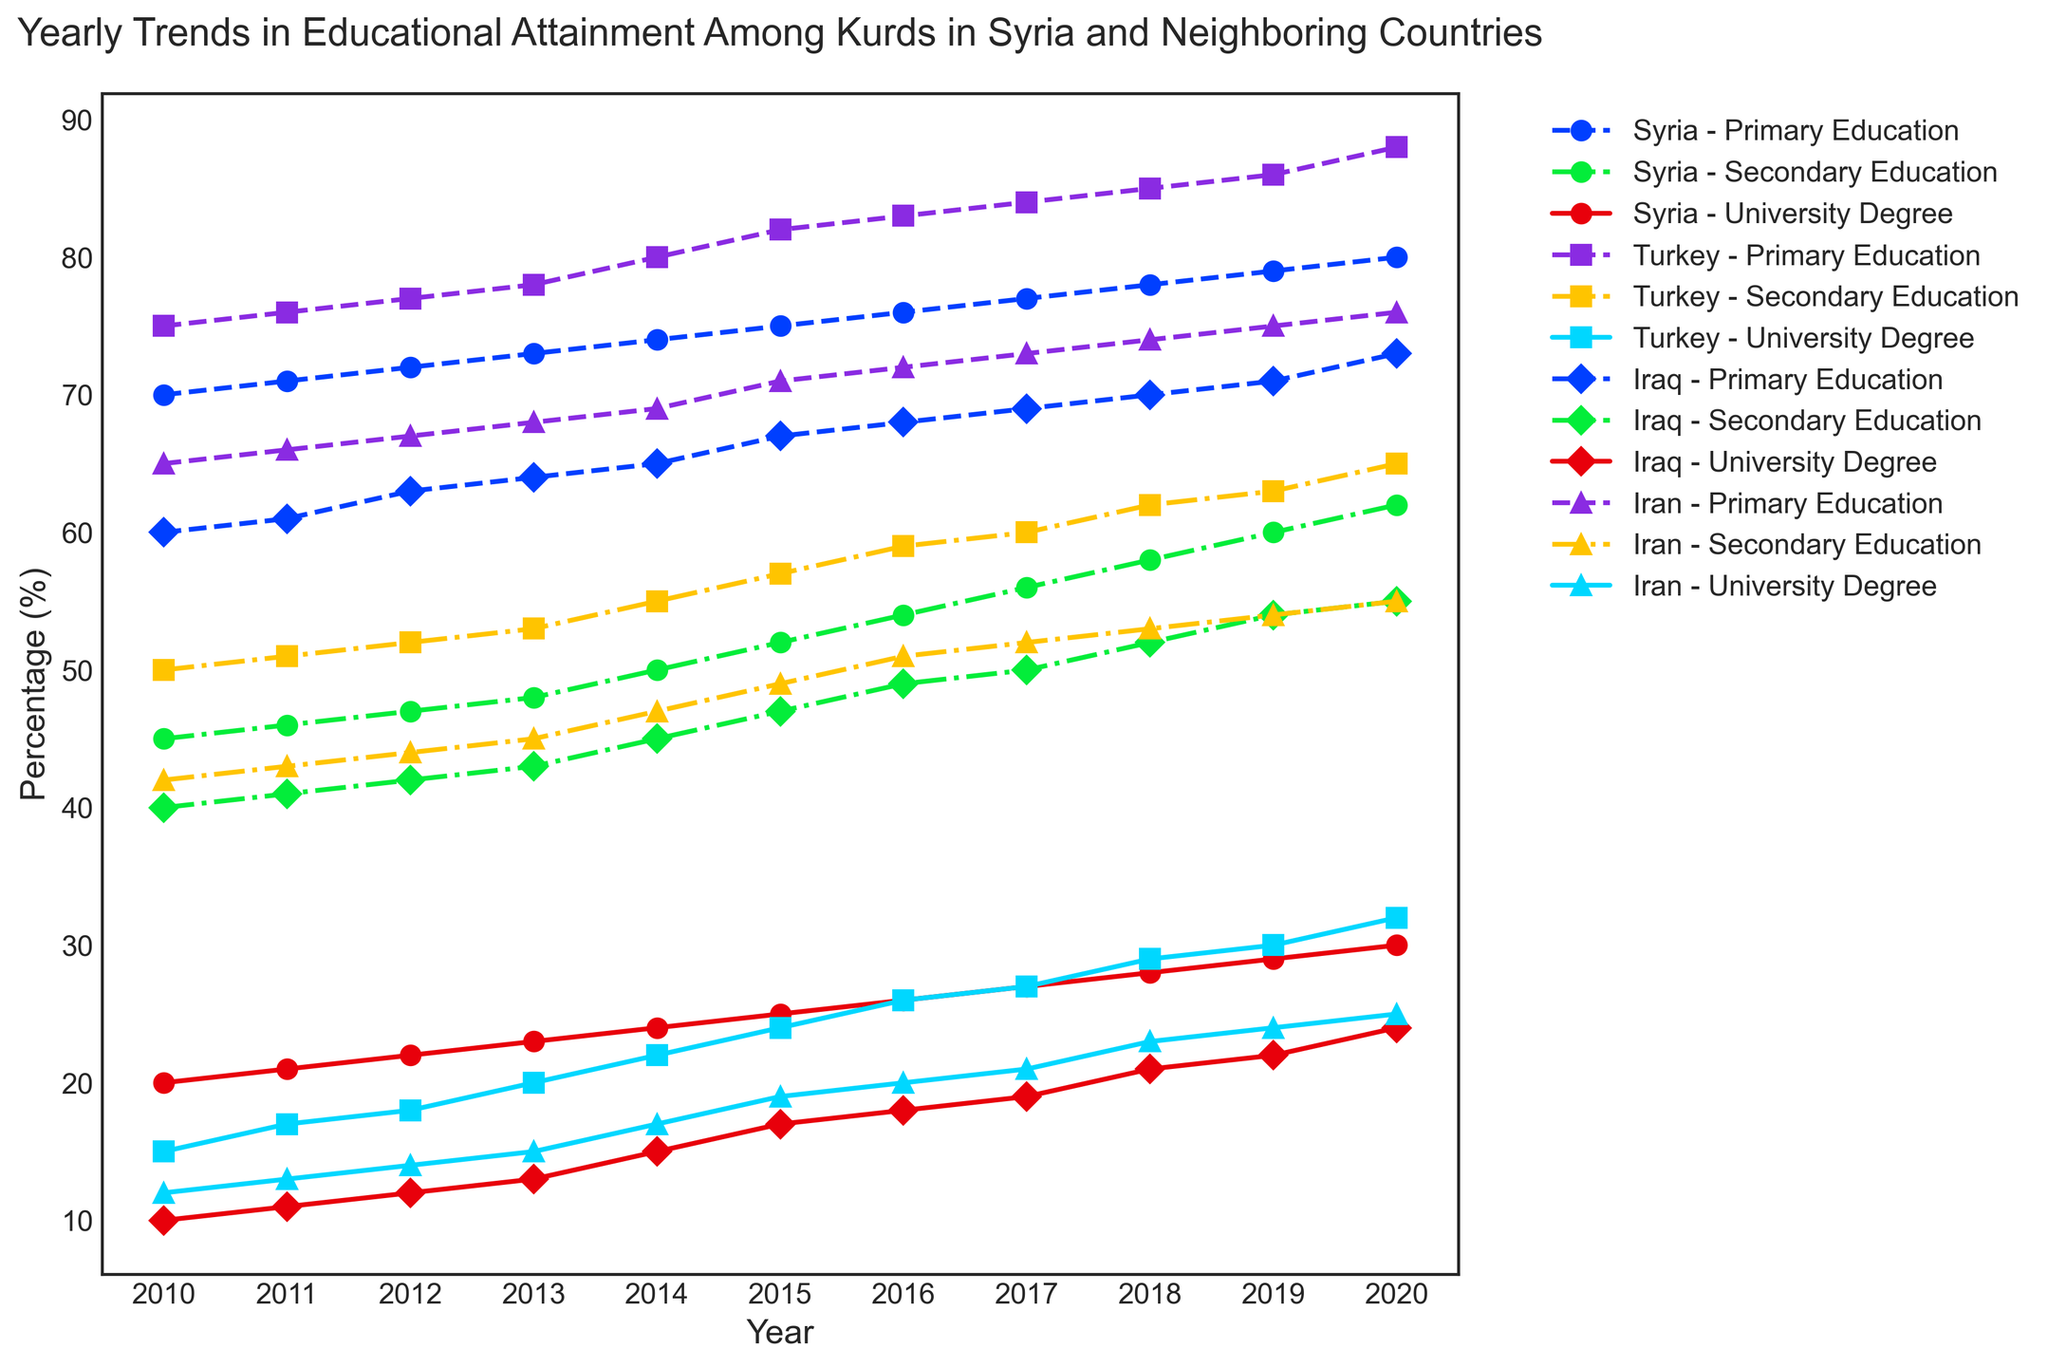Which country showed the largest increase in primary education between 2010 and 2020? To determine the largest increase in primary education for each country between 2010 and 2020, calculate the difference between the percentage in 2020 and 2010 for each country. For Syria, it's 80 - 70 = 10. For Turkey, it's 88 - 75 = 13. For Iraq, it's 73 - 60 = 13. For Iran, it's 76 - 65 = 11. Both Turkey and Iraq showed the largest increase.
Answer: Turkey and Iraq Compare the percentage of university degree attainment in Syria and Turkey in 2020. Which country had a higher percentage? Look at the percentage of university degrees for Syria and Turkey in the year 2020. Syria has 30%, and Turkey has 32%.
Answer: Turkey What is the average percentage of secondary education attainment in Iran from 2010 to 2020? To find the average, sum the percentages of secondary education in Iran from 2010 to 2020 and divide by the number of years. (42+43+44+45+47+49+51+52+53+54+55)/11 = 48
Answer: 48 Which country had the highest percentage of primary education attainment in 2018? Check the percentages of primary education for each country in 2018. Syria: 78, Turkey: 85, Iraq: 70, Iran: 74. Turkey has the highest percentage.
Answer: Turkey How did the percentage of university degree attainment in Iraq change from 2010 to 2015? Calculate the difference between the percentage in 2015 and 2010 for Iraq. 2015 has 17%, and 2010 has 10%. So, 17 - 10 = 7.
Answer: Increased by 7 What trend can be observed in the primary education percentages of Kurds in Syria from 2010 to 2020? Observe the line representing primary education for Syria from 2010 to 2020. It shows a consistent upward trend.
Answer: Consistent increase Which country had the smallest percentage of secondary education attainment in 2015? Compare the secondary education percentages in 2015 for each country. Syria: 52, Turkey: 57, Iraq: 47, Iran: 49. Iraq had the smallest percentage.
Answer: Iraq In which year did Kurds in Iran reach 50% secondary education attainment? Find the year on the plot when the secondary education line for Iran reaches 50%. It is in 2017.
Answer: 2017 What is the difference in university degree attainment between Kurds in Syria and Iran in 2019? Look at the university degree percentages for Syria and Iran in 2019. Syria: 29, Iran: 24. The difference is 29 - 24 = 5.
Answer: 5 Compare the trends of secondary education among Kurds in Iraq and Turkey from 2010 to 2020. Which country showed a steeper increase? Observe the slopes of the secondary education lines for Iraq and Turkey between 2010 and 2020. Turkey's line is steeper.
Answer: Turkey 